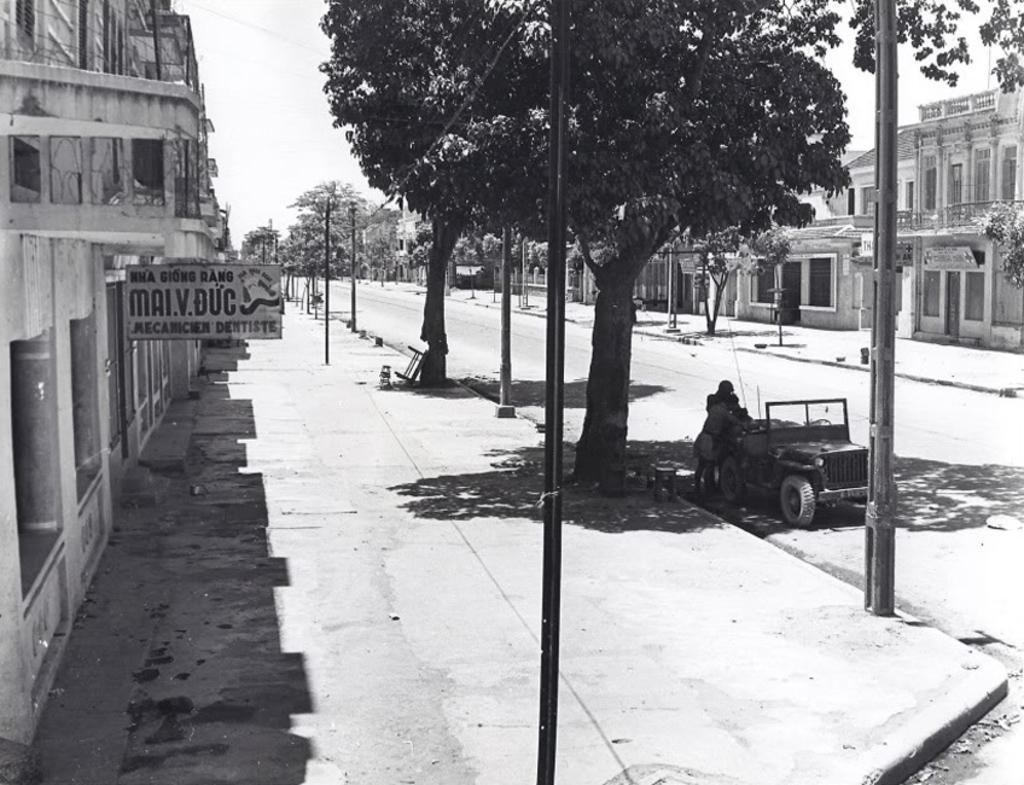Describe this image in one or two sentences. In this picture we can see a vehicle and two people standing on the road, footpaths, poles, trees, buildings, name board and in the background we can see the sky. 